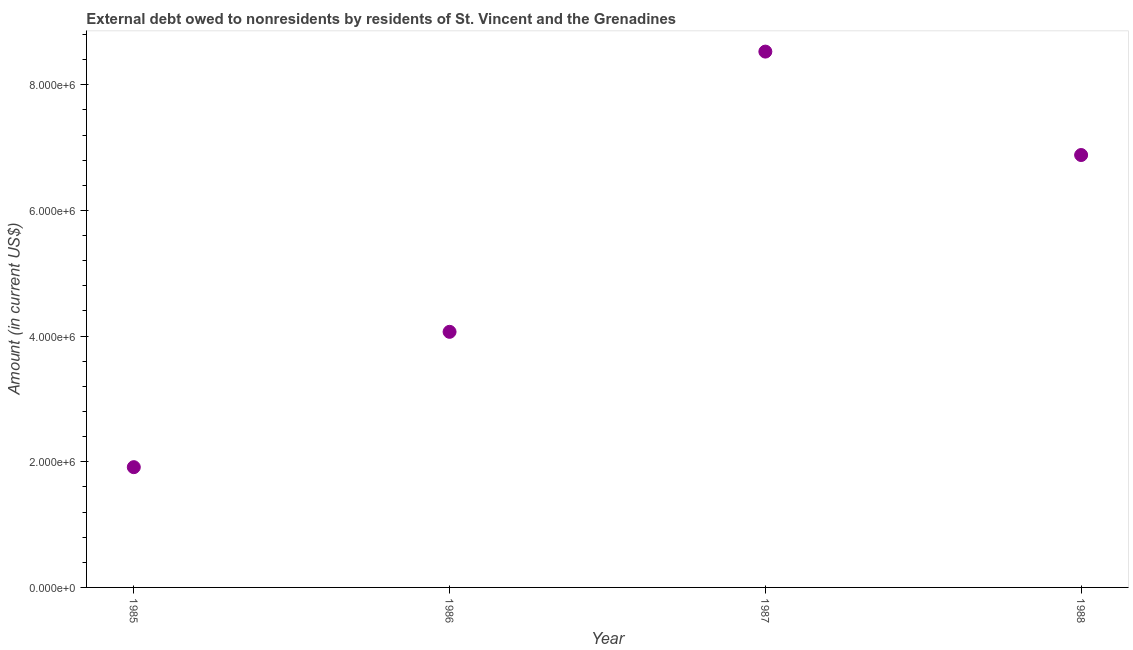What is the debt in 1988?
Your response must be concise. 6.88e+06. Across all years, what is the maximum debt?
Give a very brief answer. 8.53e+06. Across all years, what is the minimum debt?
Your answer should be very brief. 1.91e+06. In which year was the debt minimum?
Make the answer very short. 1985. What is the sum of the debt?
Your answer should be very brief. 2.14e+07. What is the difference between the debt in 1985 and 1987?
Your answer should be compact. -6.61e+06. What is the average debt per year?
Offer a terse response. 5.35e+06. What is the median debt?
Offer a very short reply. 5.48e+06. Do a majority of the years between 1985 and 1987 (inclusive) have debt greater than 4000000 US$?
Provide a short and direct response. Yes. What is the ratio of the debt in 1986 to that in 1987?
Give a very brief answer. 0.48. Is the difference between the debt in 1986 and 1987 greater than the difference between any two years?
Provide a succinct answer. No. What is the difference between the highest and the second highest debt?
Your answer should be very brief. 1.65e+06. What is the difference between the highest and the lowest debt?
Your answer should be very brief. 6.61e+06. In how many years, is the debt greater than the average debt taken over all years?
Provide a short and direct response. 2. Does the debt monotonically increase over the years?
Provide a short and direct response. No. How many dotlines are there?
Make the answer very short. 1. How many years are there in the graph?
Your answer should be very brief. 4. Does the graph contain any zero values?
Offer a very short reply. No. Does the graph contain grids?
Your response must be concise. No. What is the title of the graph?
Your answer should be compact. External debt owed to nonresidents by residents of St. Vincent and the Grenadines. What is the label or title of the X-axis?
Your answer should be compact. Year. What is the Amount (in current US$) in 1985?
Offer a terse response. 1.91e+06. What is the Amount (in current US$) in 1986?
Keep it short and to the point. 4.07e+06. What is the Amount (in current US$) in 1987?
Offer a very short reply. 8.53e+06. What is the Amount (in current US$) in 1988?
Keep it short and to the point. 6.88e+06. What is the difference between the Amount (in current US$) in 1985 and 1986?
Your answer should be very brief. -2.15e+06. What is the difference between the Amount (in current US$) in 1985 and 1987?
Offer a terse response. -6.61e+06. What is the difference between the Amount (in current US$) in 1985 and 1988?
Make the answer very short. -4.97e+06. What is the difference between the Amount (in current US$) in 1986 and 1987?
Make the answer very short. -4.46e+06. What is the difference between the Amount (in current US$) in 1986 and 1988?
Your answer should be very brief. -2.81e+06. What is the difference between the Amount (in current US$) in 1987 and 1988?
Keep it short and to the point. 1.65e+06. What is the ratio of the Amount (in current US$) in 1985 to that in 1986?
Give a very brief answer. 0.47. What is the ratio of the Amount (in current US$) in 1985 to that in 1987?
Provide a short and direct response. 0.22. What is the ratio of the Amount (in current US$) in 1985 to that in 1988?
Make the answer very short. 0.28. What is the ratio of the Amount (in current US$) in 1986 to that in 1987?
Give a very brief answer. 0.48. What is the ratio of the Amount (in current US$) in 1986 to that in 1988?
Your answer should be very brief. 0.59. What is the ratio of the Amount (in current US$) in 1987 to that in 1988?
Ensure brevity in your answer.  1.24. 